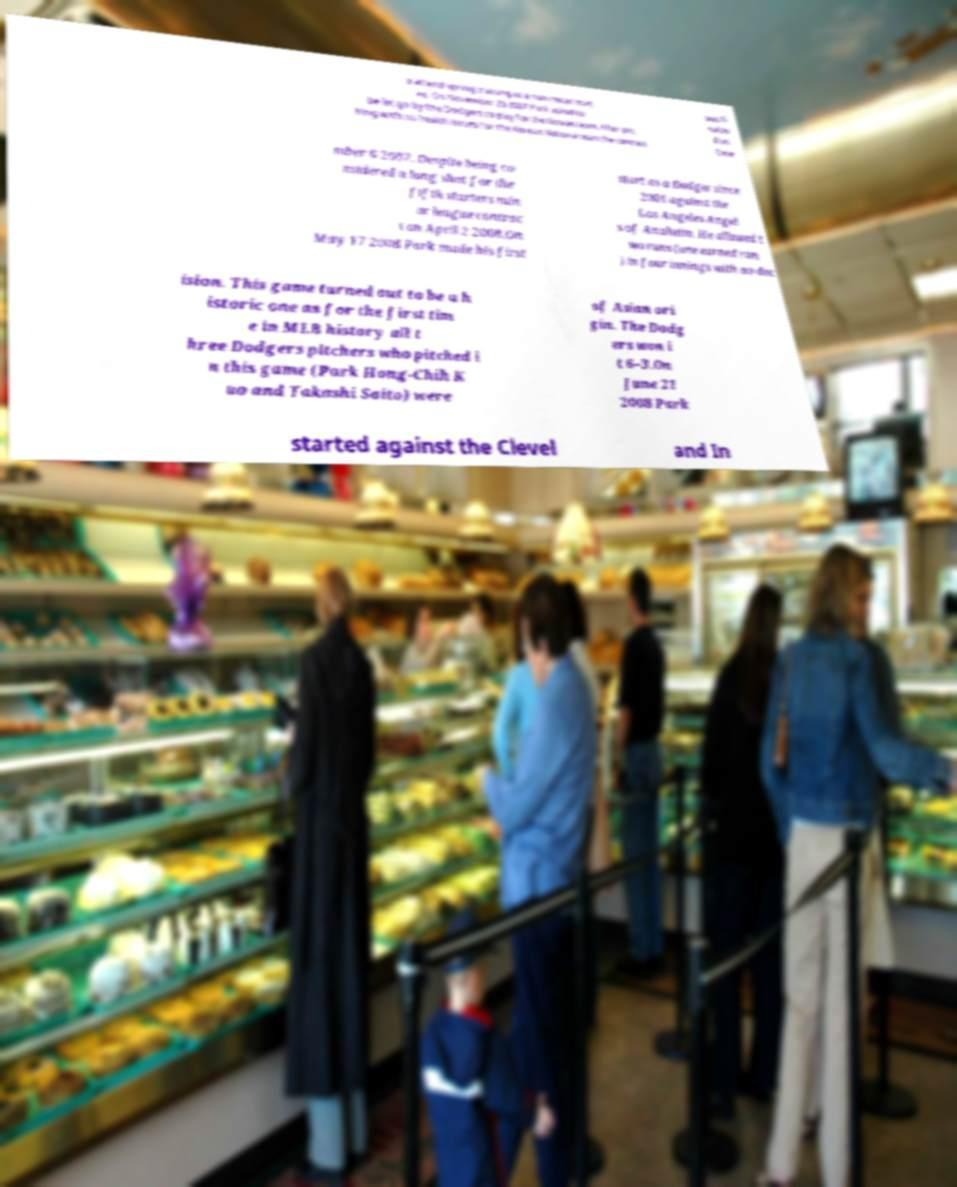Could you extract and type out the text from this image? o attend spring training as a non-roster invit ee. On November 28 2007 Park asked to be let go by the Dodgers to play for the Korean team. After pitc hing with no health issues for the Korean National team the contract was fi nalize d on Dece mber 6 2007. Despite being co nsidered a long shot for the fifth starters min or league contrac t on April 2 2008.On May 17 2008 Park made his first start as a Dodger since 2001 against the Los Angeles Angel s of Anaheim. He allowed t wo runs (one earned run ) in four innings with no dec ision. This game turned out to be a h istoric one as for the first tim e in MLB history all t hree Dodgers pitchers who pitched i n this game (Park Hong-Chih K uo and Takashi Saito) were of Asian ori gin. The Dodg ers won i t 6–3.On June 21 2008 Park started against the Clevel and In 